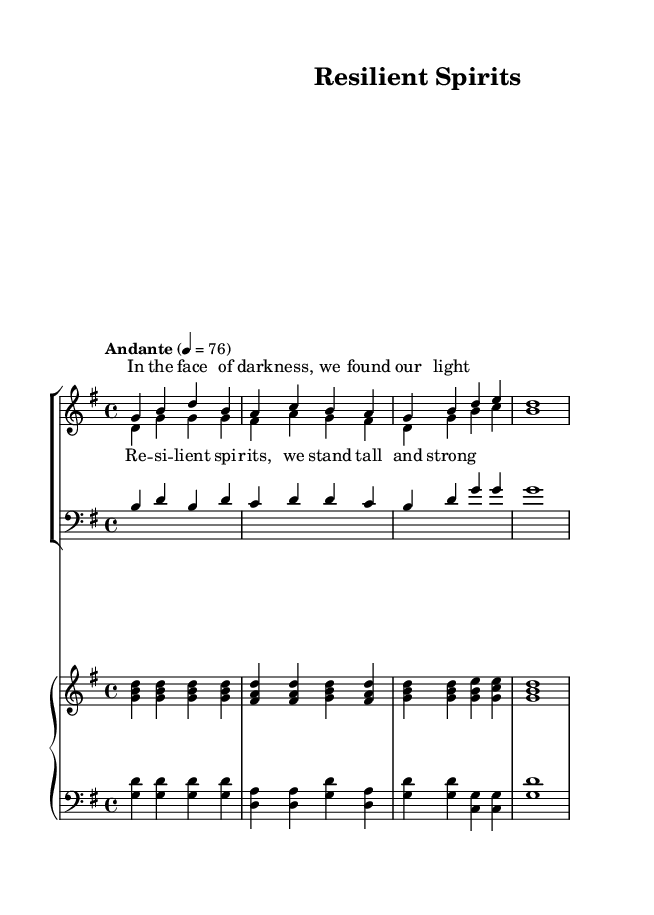What is the key signature of this music? The key signature is indicated at the beginning of the staff. In this case, it shows one sharp (F#), which corresponds to the key of G major.
Answer: G major What is the time signature of this piece? The time signature is displayed at the beginning of the music. It shows a "4/4" time signature, meaning there are four beats in each measure, and the quarter note receives one beat.
Answer: 4/4 What tempo marking is indicated for this piece? The tempo marking appears above the staff. It states "Andante," which typically means a moderately slow tempo. The metronome marking indicates a speed of 76 beats per minute.
Answer: Andante How many measures are present in the vocal parts before the first chorus? The vocal parts consist of two phrases: the verse has two measures, and the chorus has four measures. Adding them gives a total of six measures before the chorus.
Answer: 6 What instruments are included in this score? The score features a choir (women's and tenor voices) and a piano. The piano part is divided into an upper and lower staff, typically designated for right-hand and left-hand parts, respectively.
Answer: Choir and piano What is the dynamic marking indicated for the piano? The dynamic marking is not provided in this excerpt but typically would appear in the score, frequently indicating a specific mood or intensity, such as piano (soft) or forte (loud). However, if you expect soft playing throughout the piece without explicit markings, the overall feel could suggest a gentle dynamics approach.
Answer: Not specified Which voice part primarily sings the melody in this piece? The soprano part typically carries the melody in this scored arrangement, as indicated by the higher notes and lyrical emphasis in the score.
Answer: Soprano 